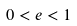Convert formula to latex. <formula><loc_0><loc_0><loc_500><loc_500>0 < e < 1</formula> 